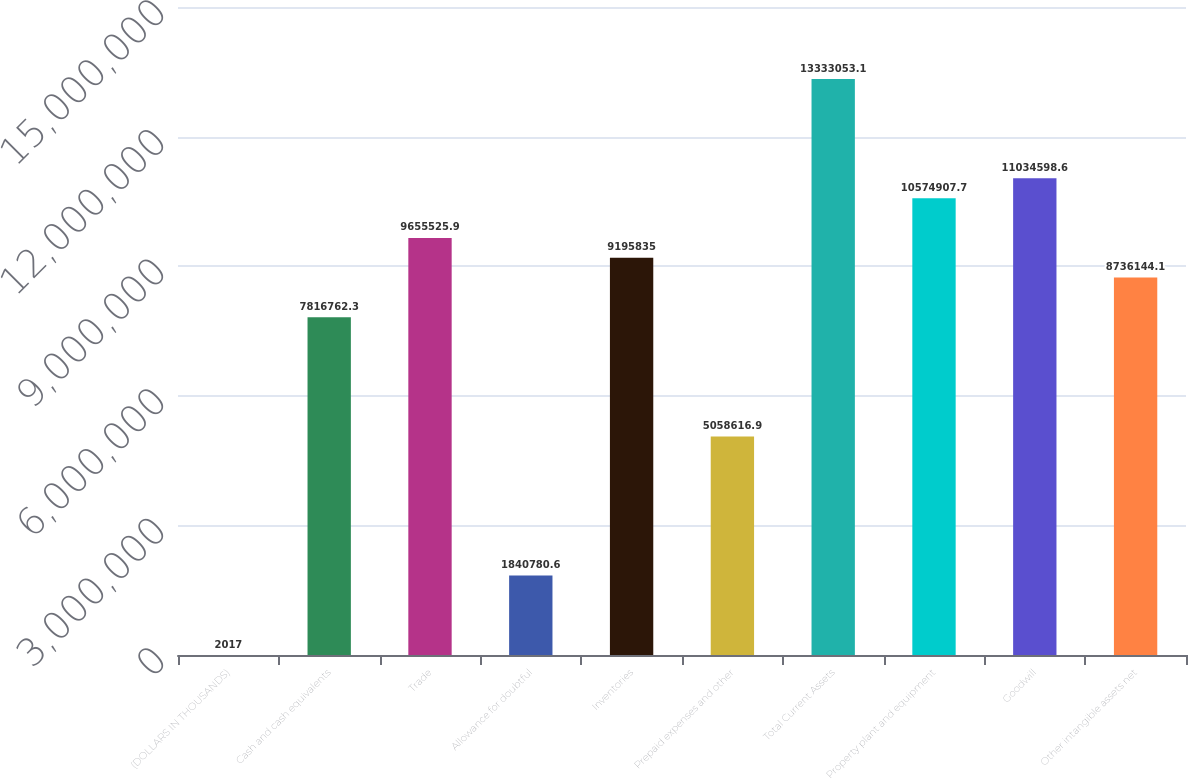Convert chart. <chart><loc_0><loc_0><loc_500><loc_500><bar_chart><fcel>(DOLLARS IN THOUSANDS)<fcel>Cash and cash equivalents<fcel>Trade<fcel>Allowance for doubtful<fcel>Inventories<fcel>Prepaid expenses and other<fcel>Total Current Assets<fcel>Property plant and equipment<fcel>Goodwill<fcel>Other intangible assets net<nl><fcel>2017<fcel>7.81676e+06<fcel>9.65553e+06<fcel>1.84078e+06<fcel>9.19584e+06<fcel>5.05862e+06<fcel>1.33331e+07<fcel>1.05749e+07<fcel>1.10346e+07<fcel>8.73614e+06<nl></chart> 